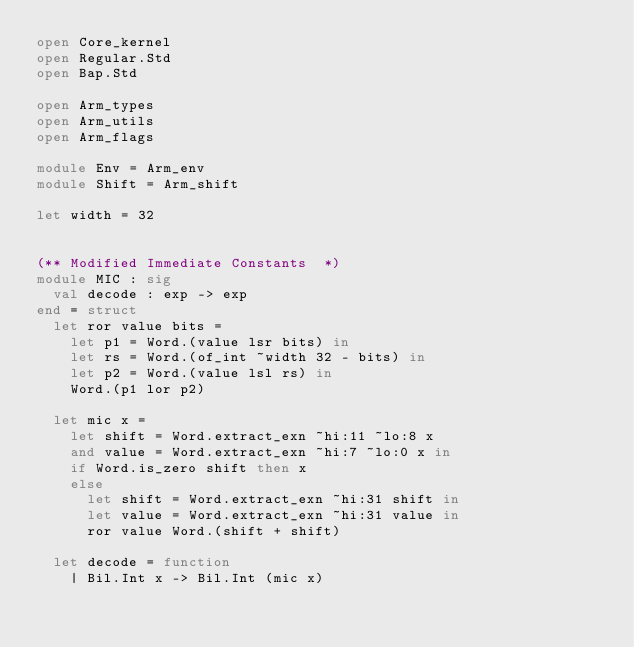<code> <loc_0><loc_0><loc_500><loc_500><_OCaml_>open Core_kernel
open Regular.Std
open Bap.Std

open Arm_types
open Arm_utils
open Arm_flags

module Env = Arm_env
module Shift = Arm_shift

let width = 32


(** Modified Immediate Constants  *)
module MIC : sig
  val decode : exp -> exp
end = struct
  let ror value bits =
    let p1 = Word.(value lsr bits) in
    let rs = Word.(of_int ~width 32 - bits) in
    let p2 = Word.(value lsl rs) in
    Word.(p1 lor p2)

  let mic x =
    let shift = Word.extract_exn ~hi:11 ~lo:8 x
    and value = Word.extract_exn ~hi:7 ~lo:0 x in
    if Word.is_zero shift then x
    else
      let shift = Word.extract_exn ~hi:31 shift in
      let value = Word.extract_exn ~hi:31 value in
      ror value Word.(shift + shift)

  let decode = function
    | Bil.Int x -> Bil.Int (mic x)</code> 